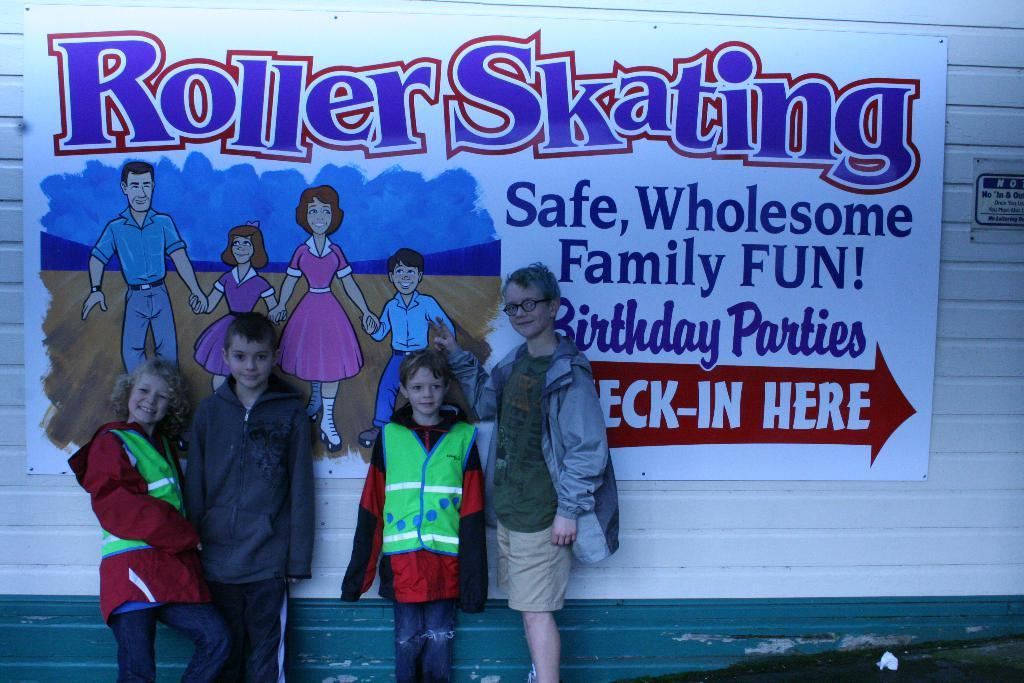<image>
Create a compact narrative representing the image presented. Four kids stand in front of a sign for a Roller Skating place. 